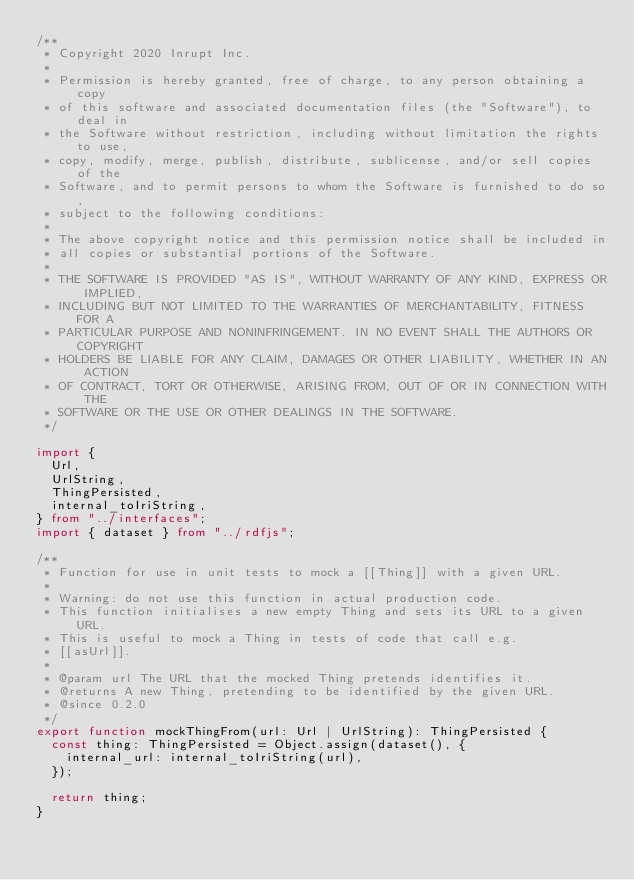Convert code to text. <code><loc_0><loc_0><loc_500><loc_500><_TypeScript_>/**
 * Copyright 2020 Inrupt Inc.
 *
 * Permission is hereby granted, free of charge, to any person obtaining a copy
 * of this software and associated documentation files (the "Software"), to deal in
 * the Software without restriction, including without limitation the rights to use,
 * copy, modify, merge, publish, distribute, sublicense, and/or sell copies of the
 * Software, and to permit persons to whom the Software is furnished to do so,
 * subject to the following conditions:
 *
 * The above copyright notice and this permission notice shall be included in
 * all copies or substantial portions of the Software.
 *
 * THE SOFTWARE IS PROVIDED "AS IS", WITHOUT WARRANTY OF ANY KIND, EXPRESS OR IMPLIED,
 * INCLUDING BUT NOT LIMITED TO THE WARRANTIES OF MERCHANTABILITY, FITNESS FOR A
 * PARTICULAR PURPOSE AND NONINFRINGEMENT. IN NO EVENT SHALL THE AUTHORS OR COPYRIGHT
 * HOLDERS BE LIABLE FOR ANY CLAIM, DAMAGES OR OTHER LIABILITY, WHETHER IN AN ACTION
 * OF CONTRACT, TORT OR OTHERWISE, ARISING FROM, OUT OF OR IN CONNECTION WITH THE
 * SOFTWARE OR THE USE OR OTHER DEALINGS IN THE SOFTWARE.
 */

import {
  Url,
  UrlString,
  ThingPersisted,
  internal_toIriString,
} from "../interfaces";
import { dataset } from "../rdfjs";

/**
 * Function for use in unit tests to mock a [[Thing]] with a given URL.
 *
 * Warning: do not use this function in actual production code.
 * This function initialises a new empty Thing and sets its URL to a given URL.
 * This is useful to mock a Thing in tests of code that call e.g.
 * [[asUrl]].
 *
 * @param url The URL that the mocked Thing pretends identifies it.
 * @returns A new Thing, pretending to be identified by the given URL.
 * @since 0.2.0
 */
export function mockThingFrom(url: Url | UrlString): ThingPersisted {
  const thing: ThingPersisted = Object.assign(dataset(), {
    internal_url: internal_toIriString(url),
  });

  return thing;
}
</code> 